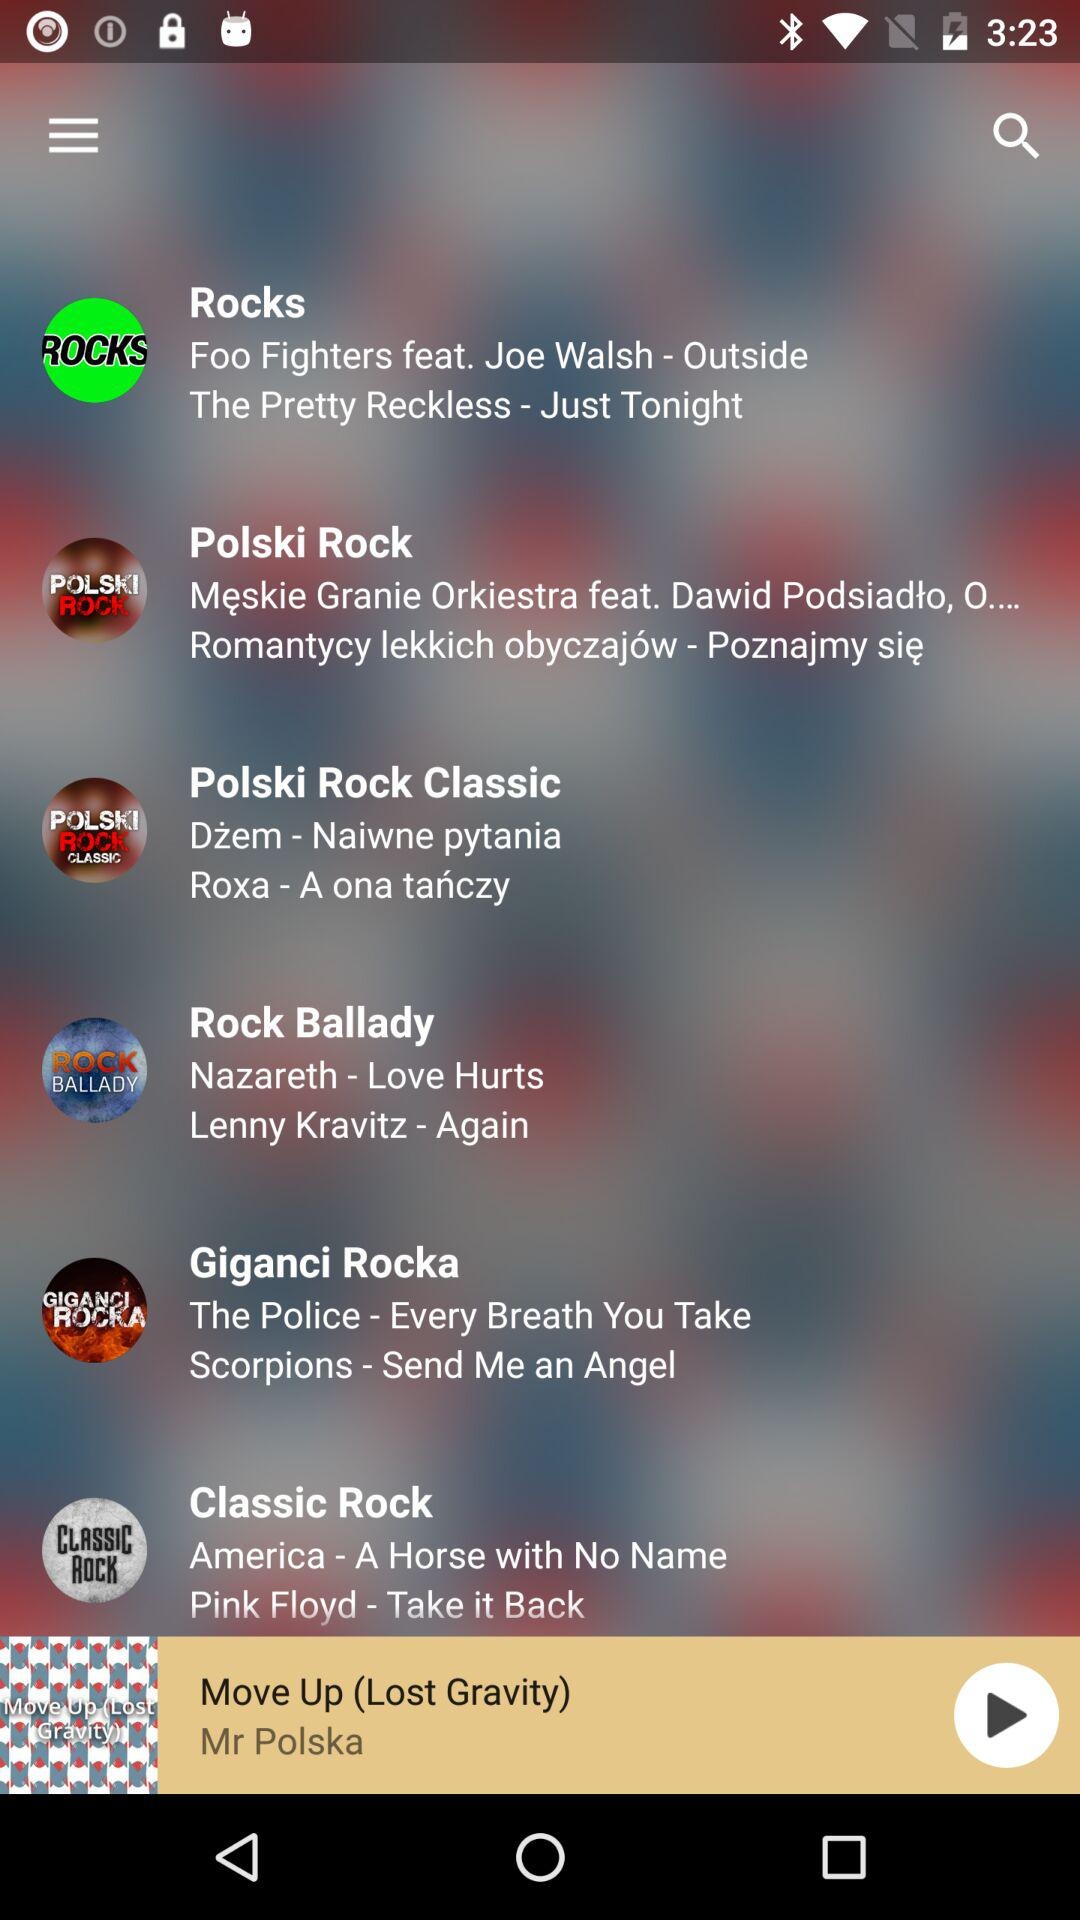Which track is playing right now? The track that is playing right now is "Move Up (Lost Gravity)". 